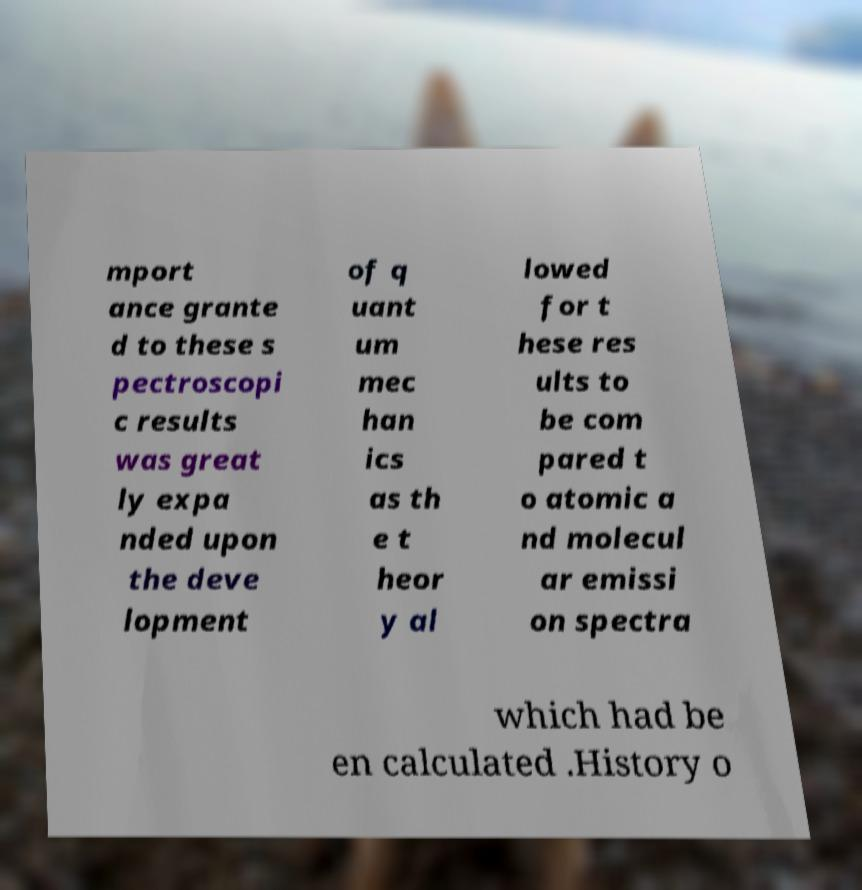What messages or text are displayed in this image? I need them in a readable, typed format. mport ance grante d to these s pectroscopi c results was great ly expa nded upon the deve lopment of q uant um mec han ics as th e t heor y al lowed for t hese res ults to be com pared t o atomic a nd molecul ar emissi on spectra which had be en calculated .History o 